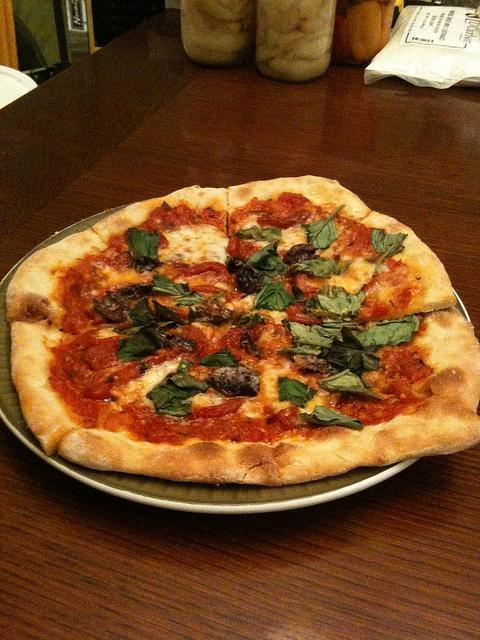How many white trucks are there in the image ?
Give a very brief answer. 0. 